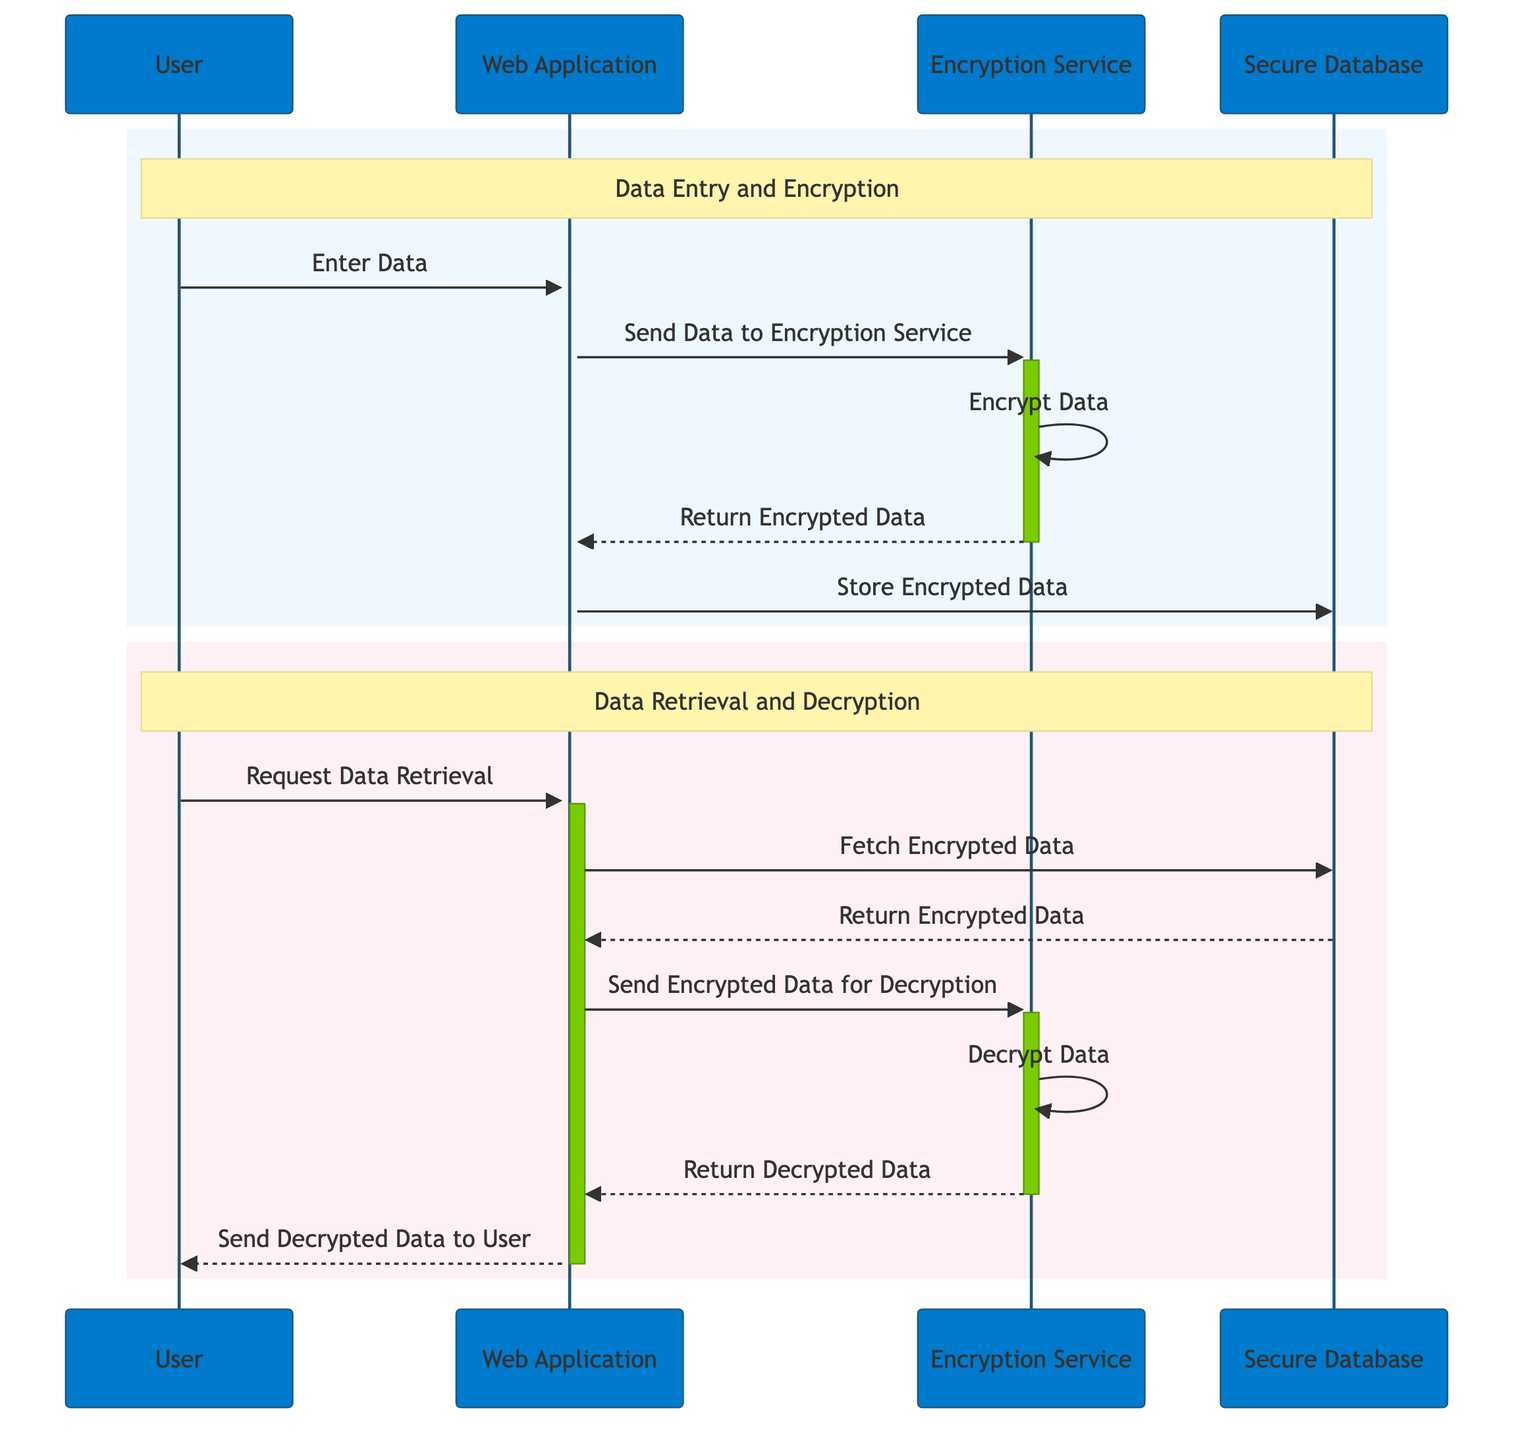What is the first action in the diagram? The first action is when the User enters data into the web application. This is represented as the arrow from the User to the Web Application labeled "Enter Data".
Answer: Enter Data How many actors are present in the sequence diagram? The diagram shows four distinct actors: User, Web Application, Encryption Service, and Secure Database. Each actor is represented at the top of the diagram.
Answer: Four Which actor handles data encryption? The Encryption Service is responsible for encrypting the data. This is shown in the step where the Web Application sends data to the Encryption Service followed by the action "Encrypt Data".
Answer: Encryption Service What is the final action in the data retrieval process? The final action is when the Web Application sends the decrypted data back to the User. This is represented as the arrow from the Web Application to the User labeled "Send Decrypted Data to User."
Answer: Send Decrypted Data to User What happens after the Web Application fetches encrypted data? After fetching the encrypted data, the Web Application sends the encrypted data to the Encryption Service for decryption. This flow is sequentially shown in the diagram.
Answer: Send Encrypted Data for Decryption Which two actions occur within the "Data Entry and Encryption" section? Within the "Data Entry and Encryption" section, the actions are "Enter Data" by the User and "Send Data to Encryption Service" by the Web Application. These actions are encapsulated in the first rectangle in the diagram.
Answer: Enter Data, Send Data to Encryption Service What is the purpose of the rectangle marked "Data Retrieval and Decryption"? The rectangle labeled "Data Retrieval and Decryption" groups all the actions related to retrieving user data and decrypting it. It highlights the steps necessary to fetch and decrypt the data from the secure database.
Answer: Grouping of actions for retrieval and decryption How many times does the Encryption Service appear in the flow? The Encryption Service appears three times: once for encryption, once when it returns the encrypted data, and once for decryption. Each appearance corresponds to distinct actions in the workflow.
Answer: Three What is the data flow direction from the Secure Database? The data flows out from the Secure Database to the Web Application when it fetches the encrypted data. This is indicated by the arrow pointing from the Secure Database to the Web Application in the retrieval phase.
Answer: Out to Web Application 